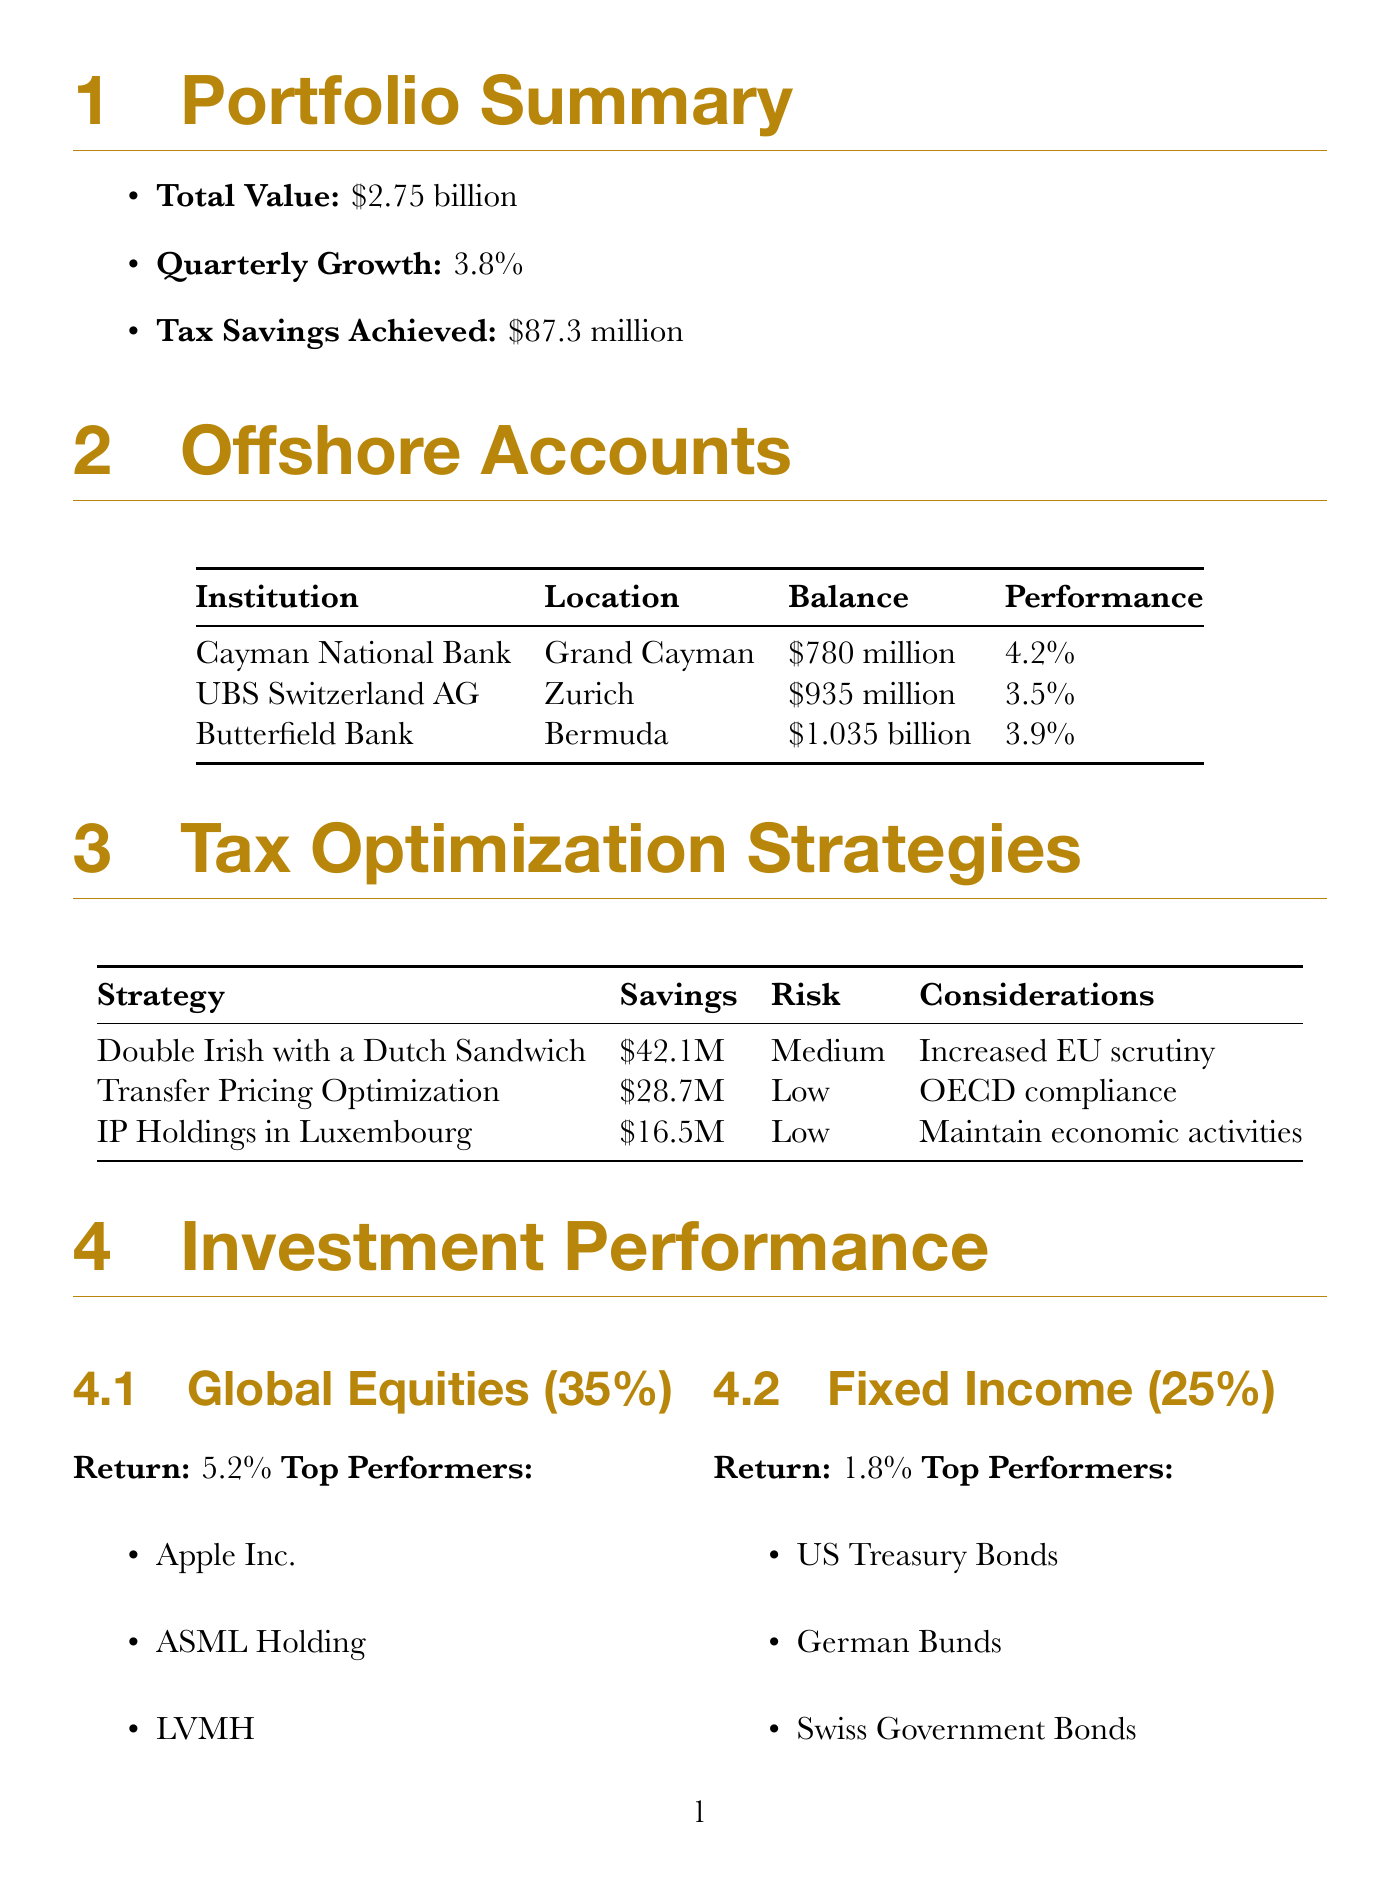what is the total value of the portfolio? The total value of the portfolio is stated in the summary section as $2.75 billion.
Answer: $2.75 billion how much tax savings were achieved this quarter? The tax savings achieved in the quarter is noted in the portfolio summary as $87.3 million.
Answer: $87.3 million which account has the highest balance? The account with the highest balance can be found in the offshore accounts section; it is Butterfield Bank with a balance of $1.035 billion.
Answer: Butterfield Bank what is the quarterly growth percentage? The quarterly growth percentage is included in the portfolio summary and is 3.8%.
Answer: 3.8% which tax optimization strategy had the highest savings? The tax optimization strategy with the highest savings is the Double Irish with a Dutch Sandwich, which saved $42.1 million.
Answer: Double Irish with a Dutch Sandwich what is the recommended action for the United States legal update? The recommended action for the United States legal update is to conduct a comprehensive review of FATCA and FBAR compliance.
Answer: Conduct comprehensive review of FATCA and FBAR compliance what potential benefit does increasing ESG-focused investments offer? The potential benefit of increasing ESG-focused investments is tax incentives and improved public perception, as outlined in the optimization recommendations.
Answer: Tax incentives and improved public perception what is the risk level of Transfer Pricing Optimization? The risk level of Transfer Pricing Optimization is classified as low in the tax optimization strategies section.
Answer: Low what is the estimated cost to establish a philanthropic foundation in Switzerland? The estimated cost to establish a philanthropic foundation in Switzerland is mentioned as $5 million.
Answer: $5 million 